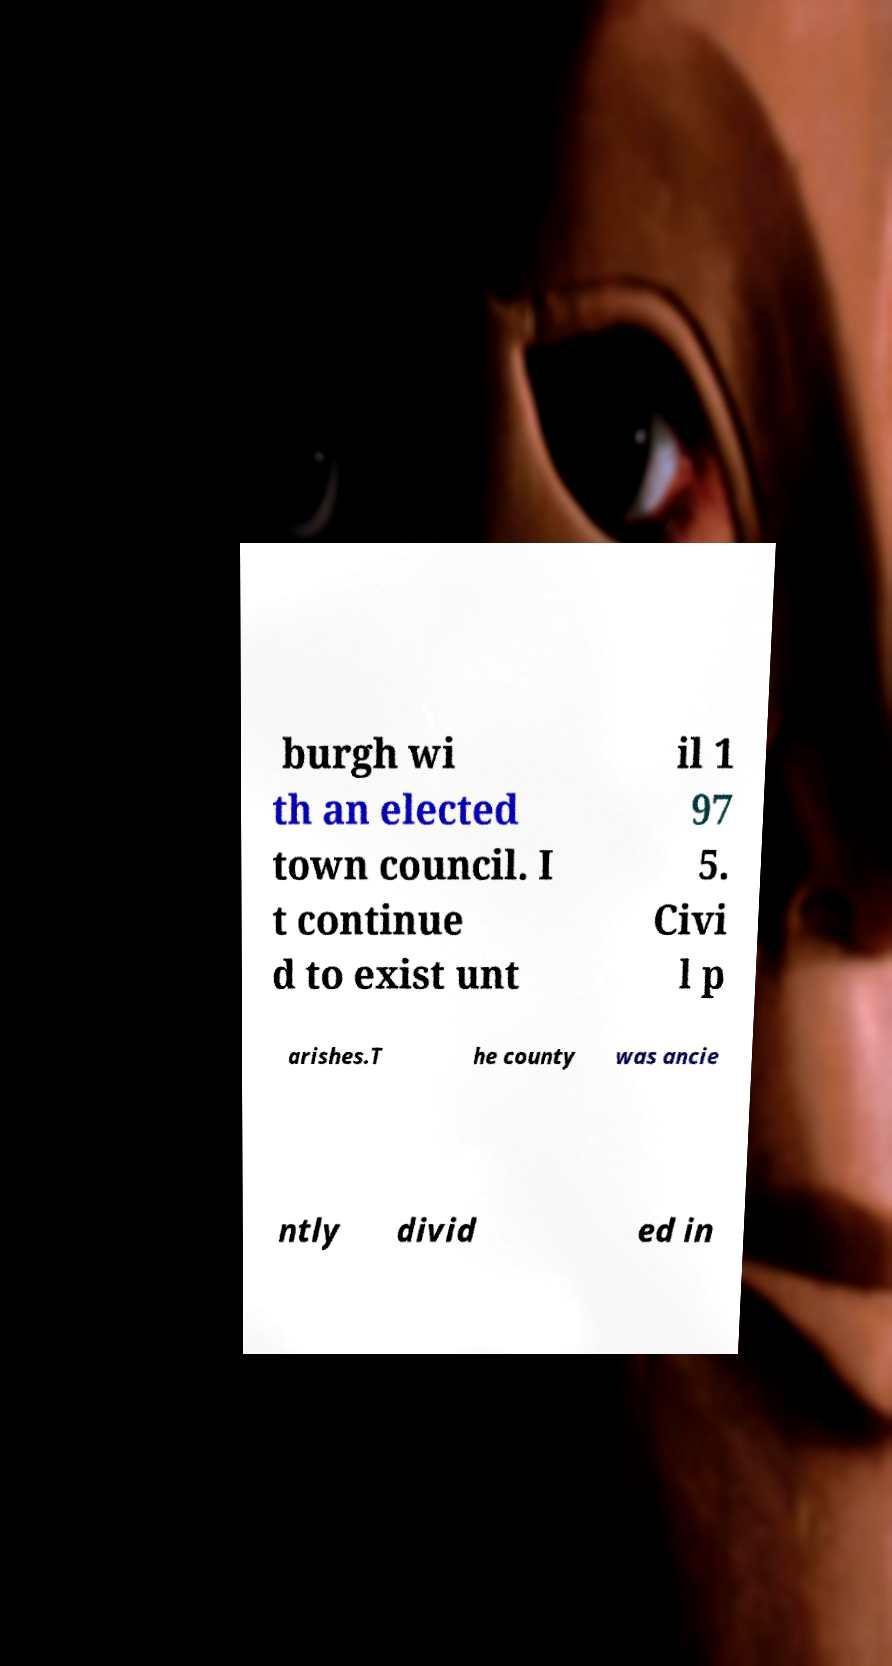Could you assist in decoding the text presented in this image and type it out clearly? burgh wi th an elected town council. I t continue d to exist unt il 1 97 5. Civi l p arishes.T he county was ancie ntly divid ed in 